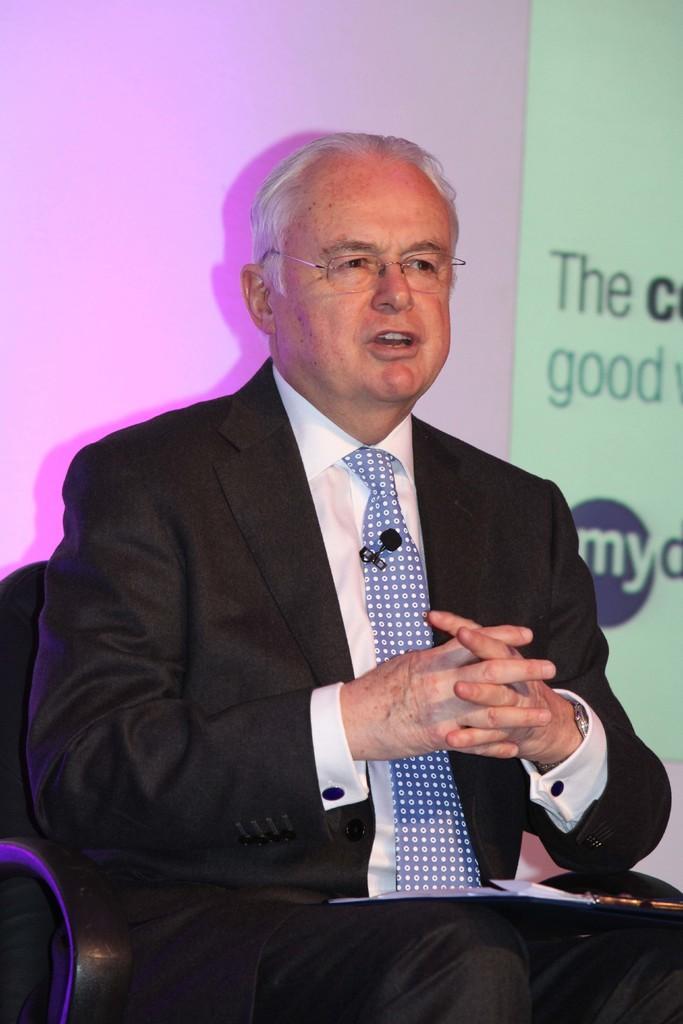In one or two sentences, can you explain what this image depicts? In the center of the image, we can see a person sitting on the chair and wearing glasses, a coat, tie and we can see a microphone and there is a paper on him. In the background, there is some text on the board. 